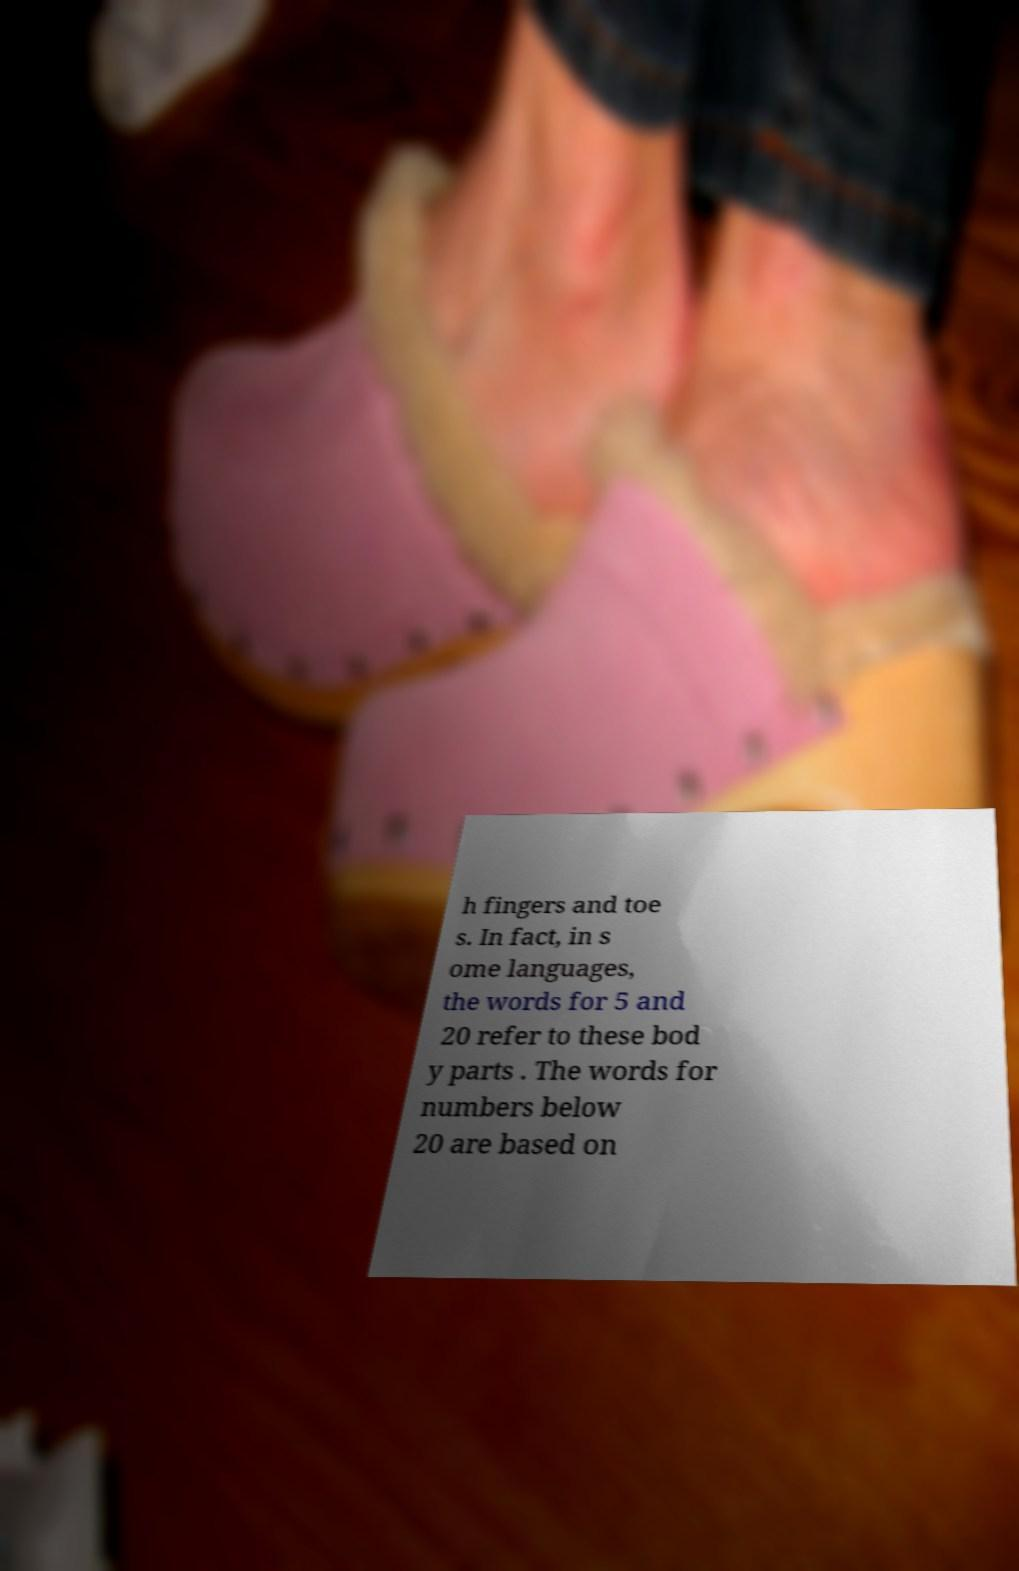There's text embedded in this image that I need extracted. Can you transcribe it verbatim? h fingers and toe s. In fact, in s ome languages, the words for 5 and 20 refer to these bod y parts . The words for numbers below 20 are based on 